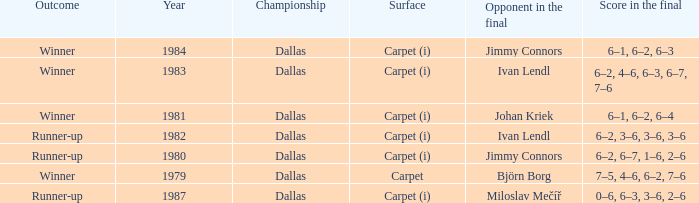How many outcomes are listed when the final opponent was Johan Kriek?  1.0. 